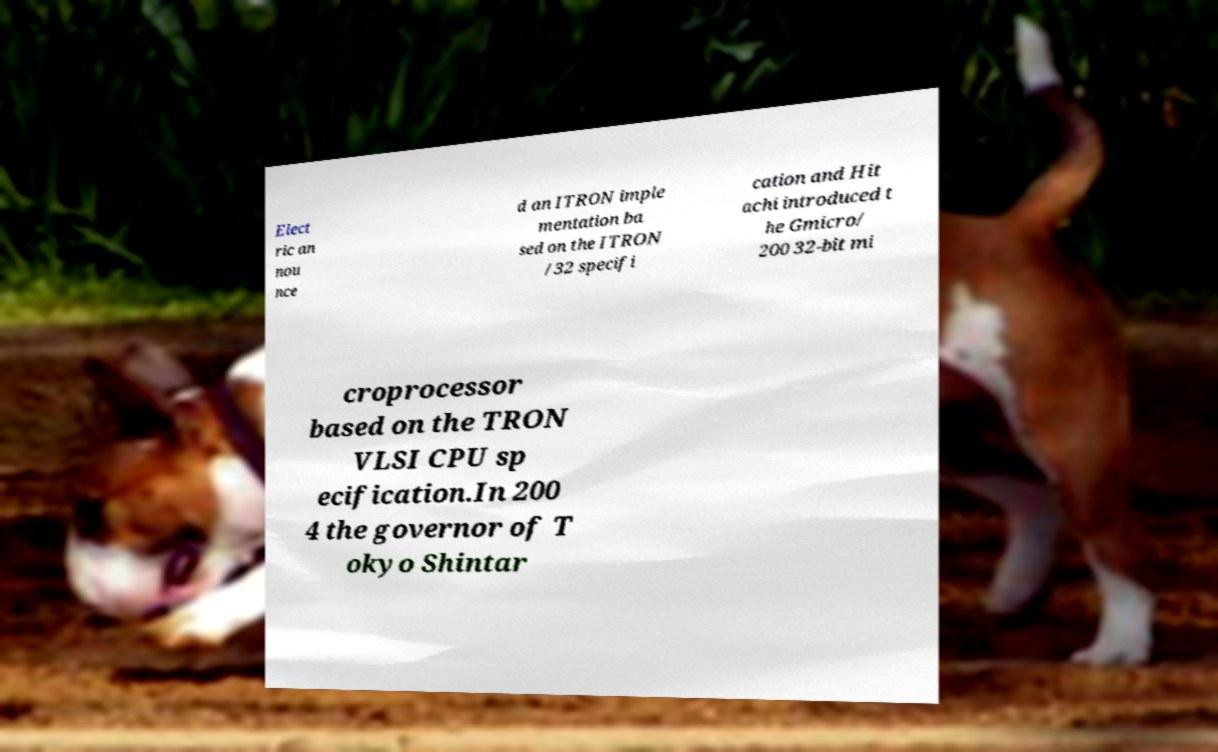Can you read and provide the text displayed in the image?This photo seems to have some interesting text. Can you extract and type it out for me? Elect ric an nou nce d an ITRON imple mentation ba sed on the ITRON /32 specifi cation and Hit achi introduced t he Gmicro/ 200 32-bit mi croprocessor based on the TRON VLSI CPU sp ecification.In 200 4 the governor of T okyo Shintar 